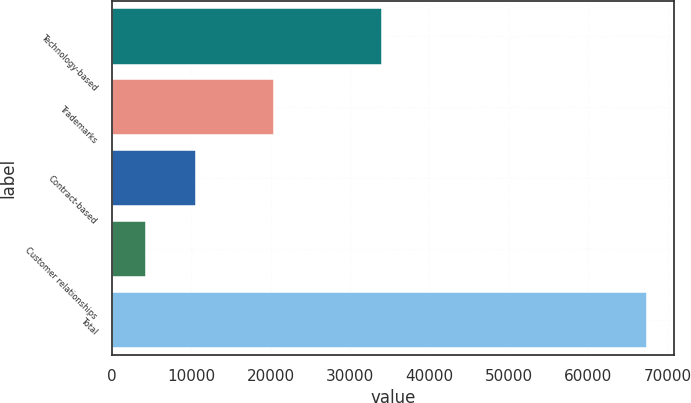Convert chart to OTSL. <chart><loc_0><loc_0><loc_500><loc_500><bar_chart><fcel>Technology-based<fcel>Trademarks<fcel>Contract-based<fcel>Customer relationships<fcel>Total<nl><fcel>34078<fcel>20424<fcel>10609.2<fcel>4294<fcel>67446<nl></chart> 